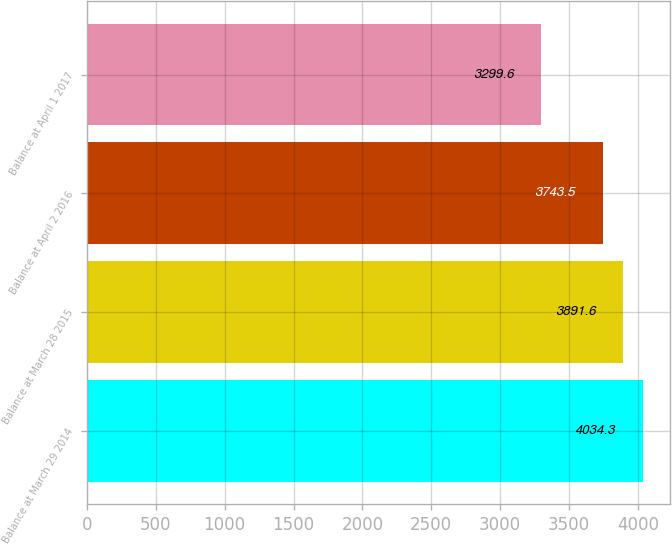Convert chart. <chart><loc_0><loc_0><loc_500><loc_500><bar_chart><fcel>Balance at March 29 2014<fcel>Balance at March 28 2015<fcel>Balance at April 2 2016<fcel>Balance at April 1 2017<nl><fcel>4034.3<fcel>3891.6<fcel>3743.5<fcel>3299.6<nl></chart> 